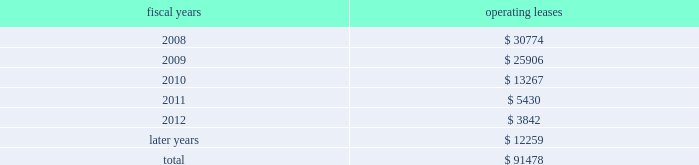Stock option gains previously deferred by those participants pursuant to the terms of the deferred compensation plan and earnings on those deferred amounts .
As a result of certain provisions of the american jobs creation act , participants had the opportunity until december 31 , 2005 to elect to withdraw amounts previously deferred .
11 .
Lease commitments the company leases certain of its facilities , equipment and software under various operating leases that expire at various dates through 2022 .
The lease agreements frequently include renewal and escalation clauses and require the company to pay taxes , insurance and maintenance costs .
Total rental expense under operating leases was approximately $ 43 million in fiscal 2007 , $ 45 million in fiscal 2006 and $ 44 million in fiscal 2005 .
The following is a schedule of future minimum rental payments required under long-term operating leases at november 3 , 2007 : fiscal years operating leases .
12 .
Commitments and contingencies tentative settlement of the sec 2019s previously announced stock option investigation in the company 2019s 2004 form 10-k filing , the company disclosed that the securities and exchange com- mission ( sec ) had initiated an inquiry into its stock option granting practices , focusing on options that were granted shortly before the issuance of favorable financial results .
On november 15 , 2005 , the company announced that it had reached a tentative settlement with the sec .
At all times since receiving notice of this inquiry , the company has cooperated with the sec .
In november 2005 , the company and its president and ceo , mr .
Jerald g .
Fishman , made an offer of settlement to the staff of the sec .
The settlement has been submitted to the commission for approval .
There can be no assurance a final settlement will be so approved .
The sec 2019s inquiry focused on two separate issues .
The first issue concerned the company 2019s disclosure regarding grants of options to employees and directors prior to the release of favorable financial results .
Specifically , the issue related to options granted to employees ( including officers ) of the company on november 30 , 1999 and to employees ( including officers ) and directors of the company on november 10 , 2000 .
The second issue concerned the grant dates for options granted to employees ( including officers ) in 1998 and 1999 , and the grant date for options granted to employees ( including officers ) and directors in 2001 .
Specifically , the settlement would conclude that the appropriate grant date for the september 4 , 1998 options should have been september 8th ( which is one trading day later than the date that was used to price the options ) ; the appropriate grant date for the november 30 , 1999 options should have been november 29th ( which is one trading day earlier than the date that was used ) ; and the appropriate grant date for the july 18 , 2001 options should have been july 26th ( which is five trading days after the original date ) .
Analog devices , inc .
Notes to consolidated financial statements 2014 ( continued ) .
What is the growth rate in rental expense under operating leases in 2007? 
Computations: ((43 - 45) / 45)
Answer: -0.04444. 